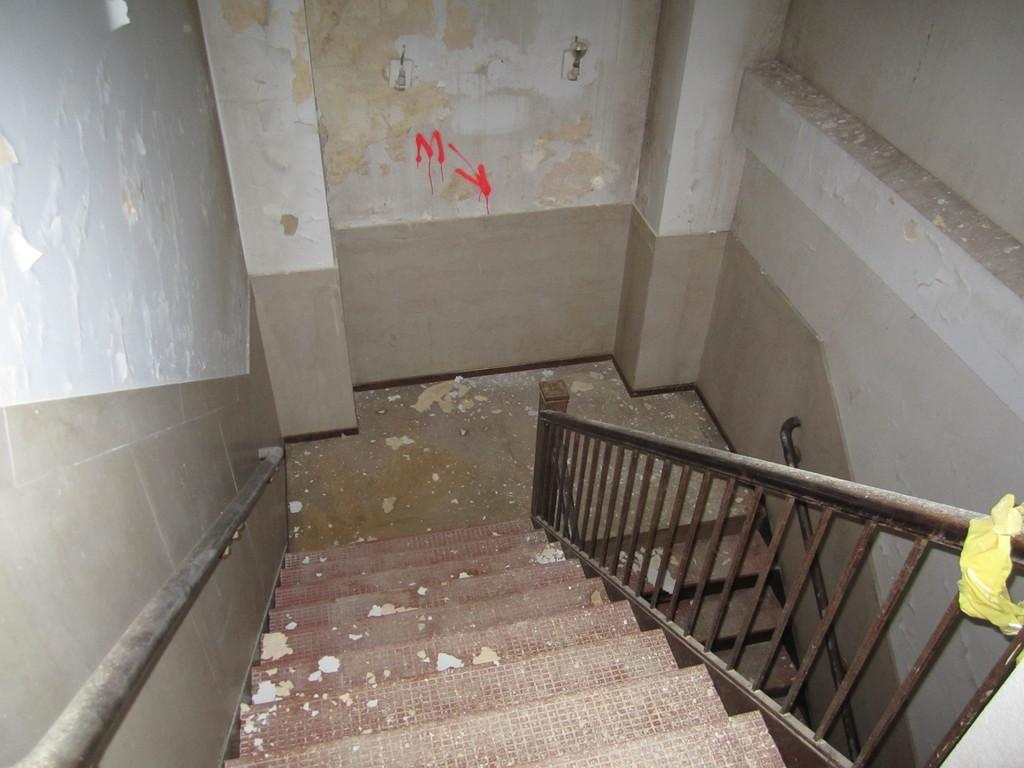What type of structure can be seen in the image? There are stairs, a metal fence, and a wall visible in the image. What material is the fence made of? The fence in the image is made of metal. What is written on the wall in the image? There is text written on the wall in the image. What type of insurance policy is mentioned on the wall in the image? There is no mention of insurance in the image; only text is written on the wall. 